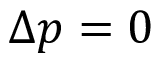<formula> <loc_0><loc_0><loc_500><loc_500>\Delta p = 0</formula> 